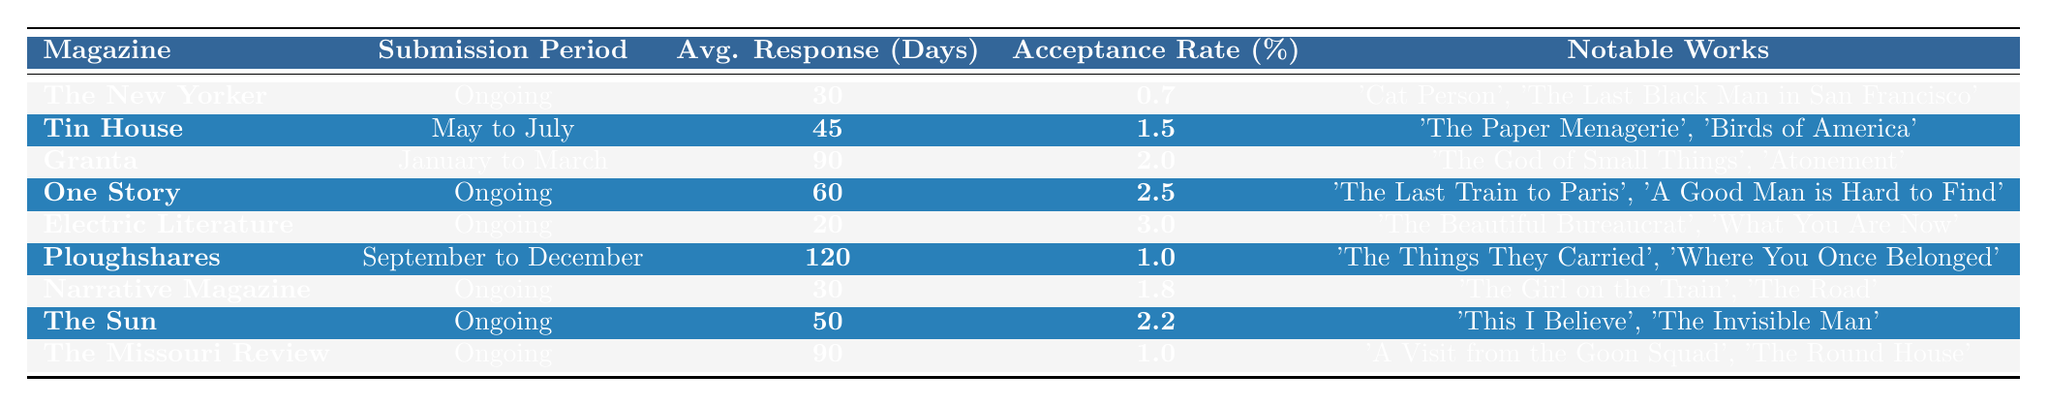What is the acceptance rate of The New Yorker? The acceptance rate for The New Yorker is specified in the table as 0.7%.
Answer: 0.7% How long does it take on average for Tin House to respond to submissions? According to the table, Tin House has an average response time of 45 days.
Answer: 45 days Which literary magazine has the highest acceptance rate? The acceptance rates for the magazines are listed, and Electric Literature has the highest at 3.0%.
Answer: 3.0% Is the submission period for Granta open year-round? The table shows that Granta's submission period is limited to January to March, so it is not open year-round.
Answer: No What is the average response time for ongoing submissions across all listed magazines? The ongoing magazines with their response times are The New Yorker (30 days), One Story (60 days), Electric Literature (20 days), Narrative Magazine (30 days), The Sun (50 days), and The Missouri Review (90 days). The total response time is 30 + 60 + 20 + 30 + 50 + 90 = 280 days, and there are 6 ongoing magazines, so the average is 280/6 = 46.67 days.
Answer: 46.67 days Which magazine has the longest average response time? The table shows that Ploughshares has the longest average response time of 120 days.
Answer: 120 days How many magazines have an acceptance rate of 1% or higher? Checking the acceptance rates listed in the table, the magazines with rates of 1% or higher are Tin House (1.5%), Granta (2.0%), One Story (2.5%), Electric Literature (3.0%), Narrative Magazine (1.8%), The Sun (2.2%), The Missouri Review (1.0%). This counts to a total of 7 magazines.
Answer: 7 What is the difference in average response time between Electric Literature and The Missouri Review? Electric Literature's average response time is 20 days, while The Missouri Review's is 90 days. The difference is 90 - 20 = 70 days.
Answer: 70 days Are submissions to Ploughshares accepted in any month other than September to December? The table specifies that Ploughshares only accepts submissions from September to December, indicating it is not accepted in other months.
Answer: No Which notable work was published in Electric Literature? The table lists 'The Beautiful Bureaucrat' and 'What You Are Now' as notable works for Electric Literature.
Answer: 'The Beautiful Bureaucrat' and 'What You Are Now' What is the average acceptance rate of the magazines that are open for submissions all year? The magazines open for ongoing submissions are The New Yorker (0.7%), One Story (2.5%), Electric Literature (3.0%), Narrative Magazine (1.8%), The Sun (2.2%), and The Missouri Review (1.0%). Summing these rates gives 0.7 + 2.5 + 3.0 + 1.8 + 2.2 + 1.0 = 11.2%, and dividing by 6 gives an average of 11.2/6 = 1.87%.
Answer: 1.87% 